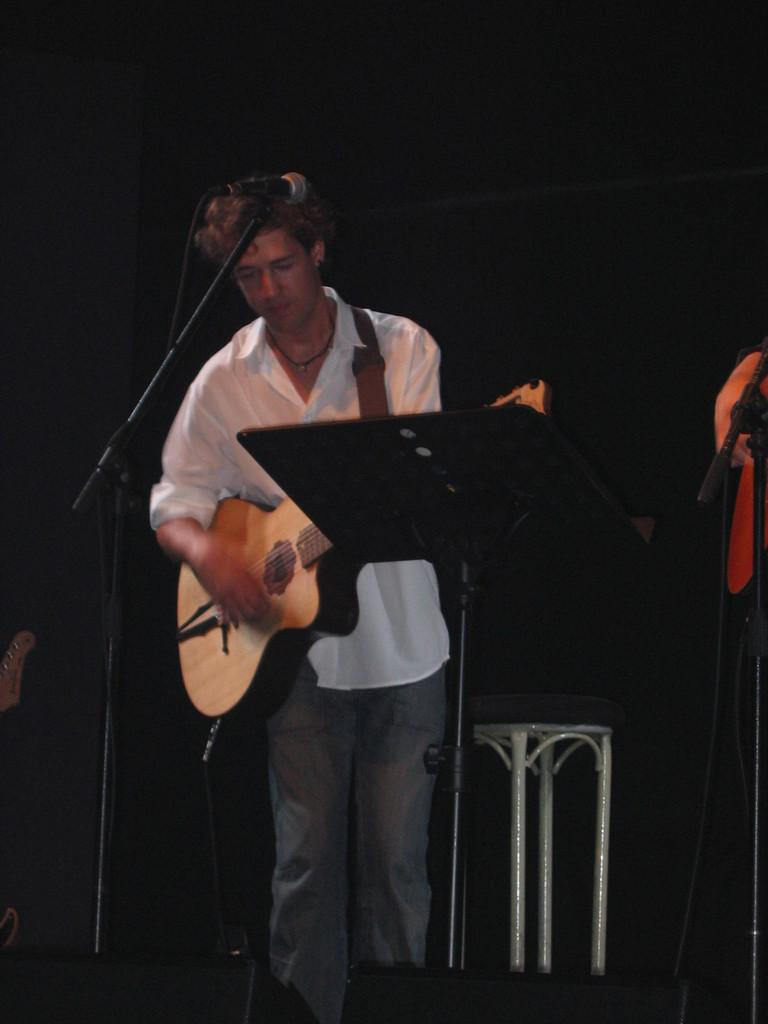Who is the main subject in the image? There is a man in the image. What is the man doing in the image? The man is playing a guitar. What object is present in the image that is commonly used for amplifying sound? There is a microphone in the image. Can you see any yaks or snails in the image? No, there are no yaks or snails present in the image. Is the man playing the guitar at a zoo in the image? The location of the image is not specified, so we cannot determine if it is at a zoo or not. 